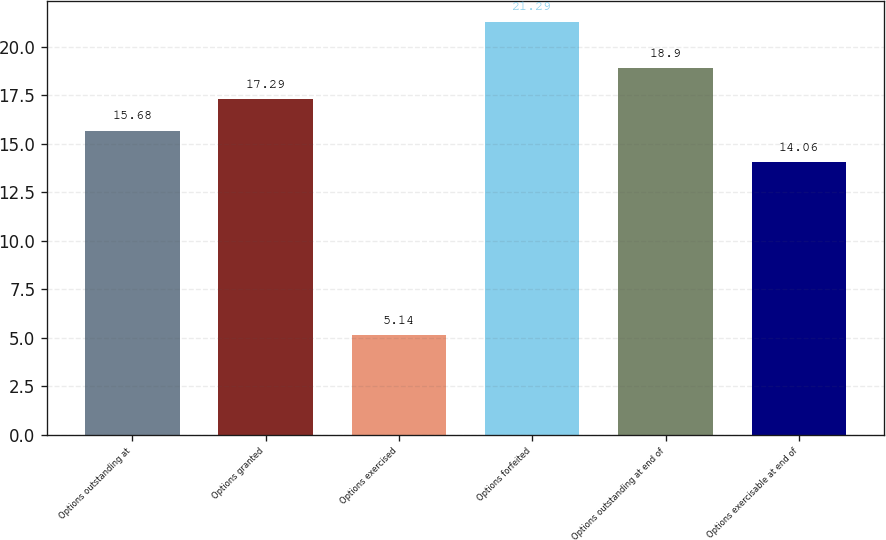<chart> <loc_0><loc_0><loc_500><loc_500><bar_chart><fcel>Options outstanding at<fcel>Options granted<fcel>Options exercised<fcel>Options forfeited<fcel>Options outstanding at end of<fcel>Options exercisable at end of<nl><fcel>15.68<fcel>17.29<fcel>5.14<fcel>21.29<fcel>18.9<fcel>14.06<nl></chart> 